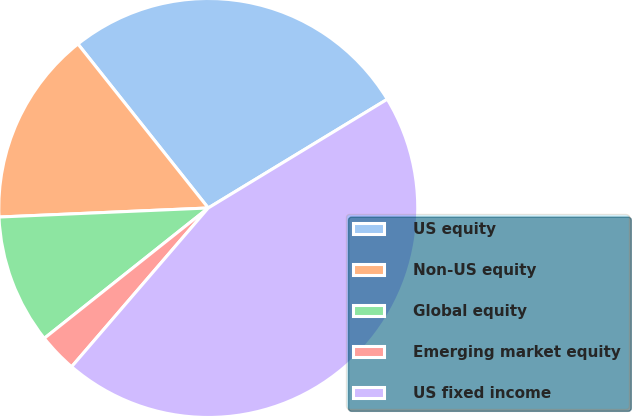Convert chart to OTSL. <chart><loc_0><loc_0><loc_500><loc_500><pie_chart><fcel>US equity<fcel>Non-US equity<fcel>Global equity<fcel>Emerging market equity<fcel>US fixed income<nl><fcel>27.0%<fcel>15.0%<fcel>10.0%<fcel>3.0%<fcel>45.0%<nl></chart> 